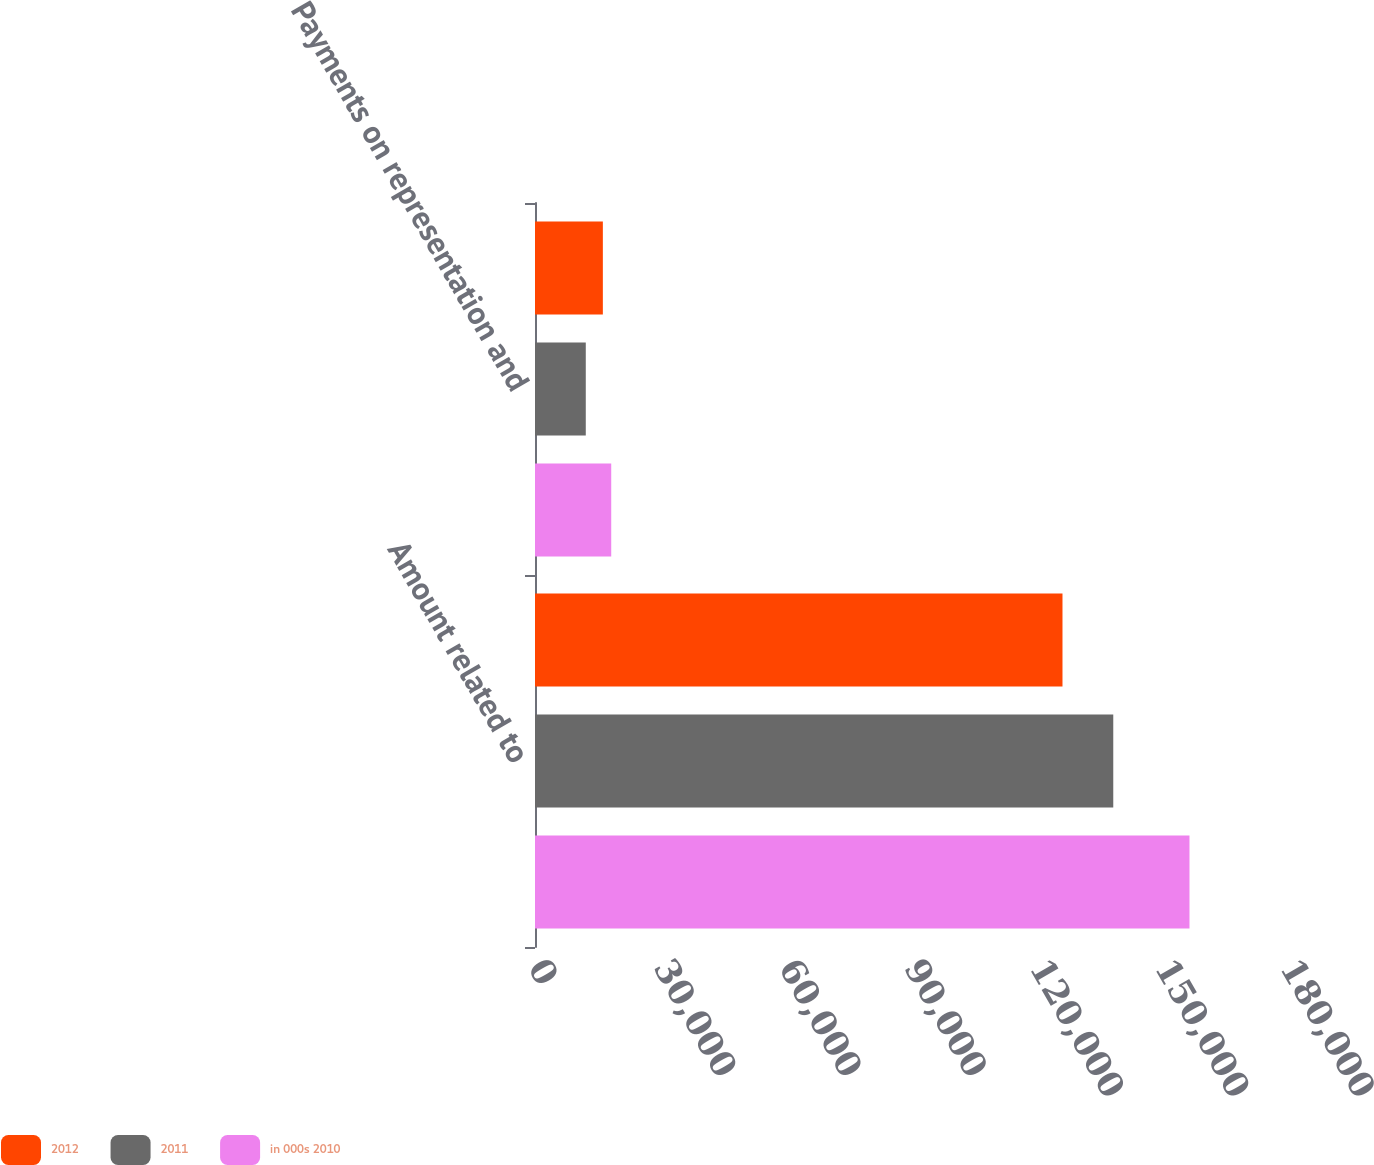Convert chart. <chart><loc_0><loc_0><loc_500><loc_500><stacked_bar_chart><ecel><fcel>Amount related to<fcel>Payments on representation and<nl><fcel>2012<fcel>126260<fcel>16242<nl><fcel>2011<fcel>138415<fcel>12155<nl><fcel>in 000s 2010<fcel>156659<fcel>18244<nl></chart> 